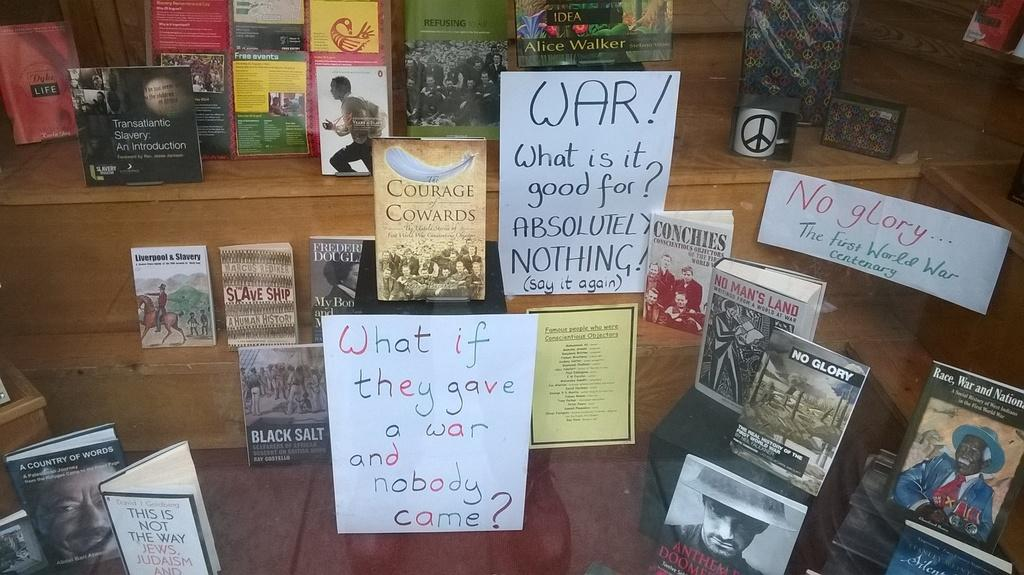<image>
Share a concise interpretation of the image provided. A book display that also features some anti war slogans. 